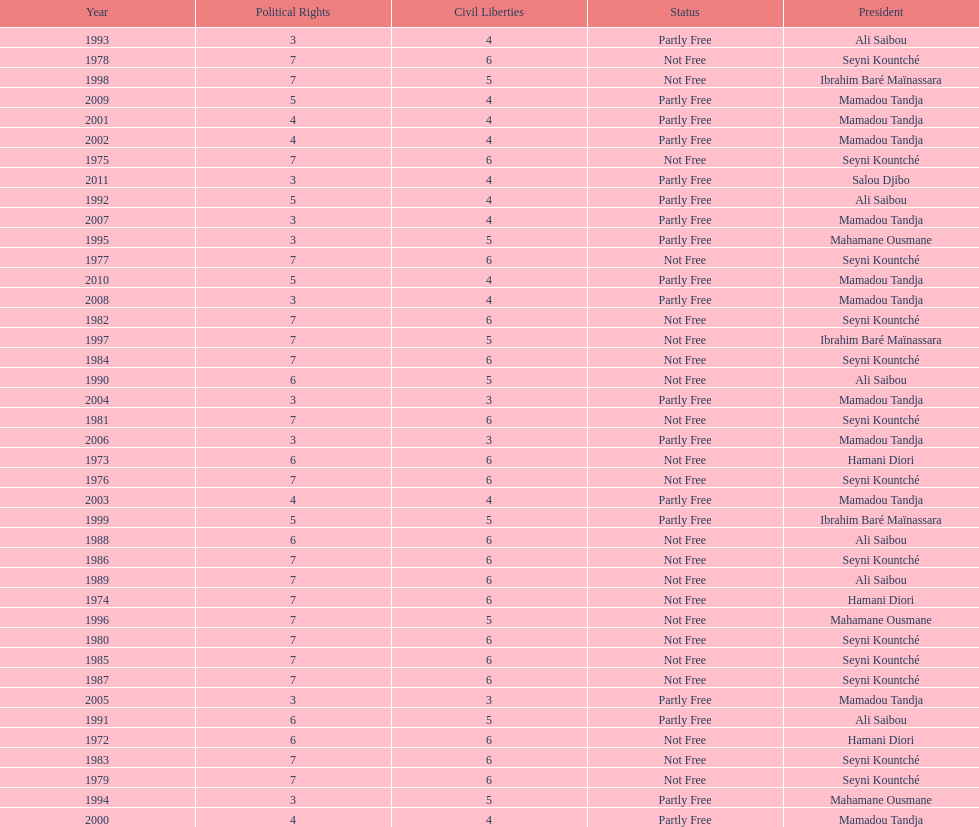How long did it take for civil liberties to decrease below 6? 18 years. 